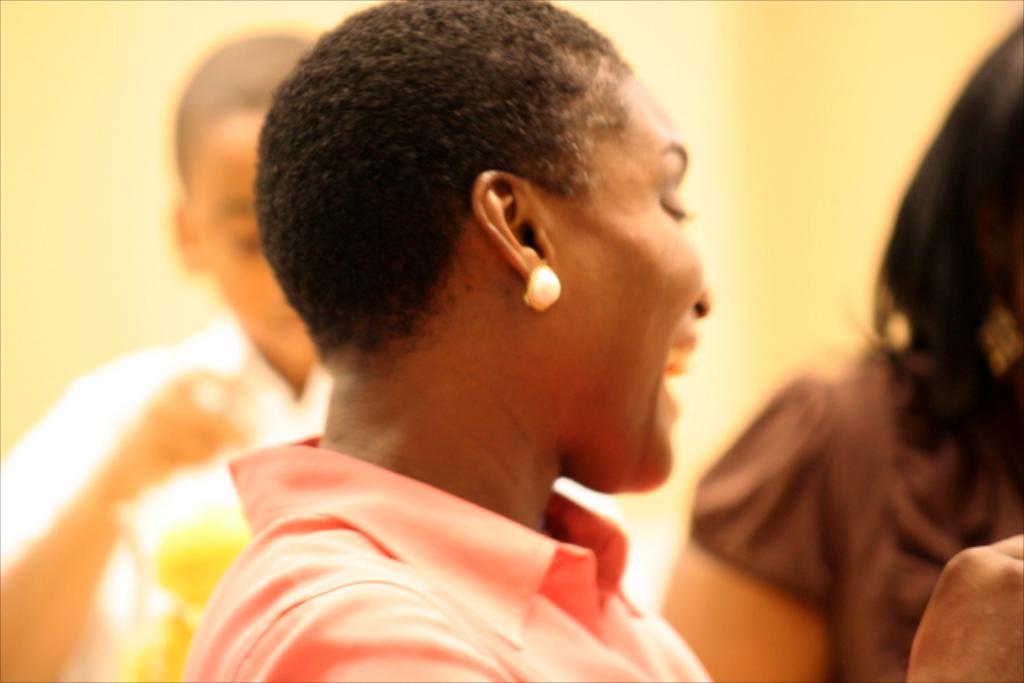What is the main subject of the image? The main subject of the image is people. Can you describe the expressions of the people in the image? One person is smiling in the image. What can be seen in the background of the image? The background of the image is light colored. What type of paper is being used for the protest in the image? There is no protest or paper present in the image; it features people in the center with one person smiling. 